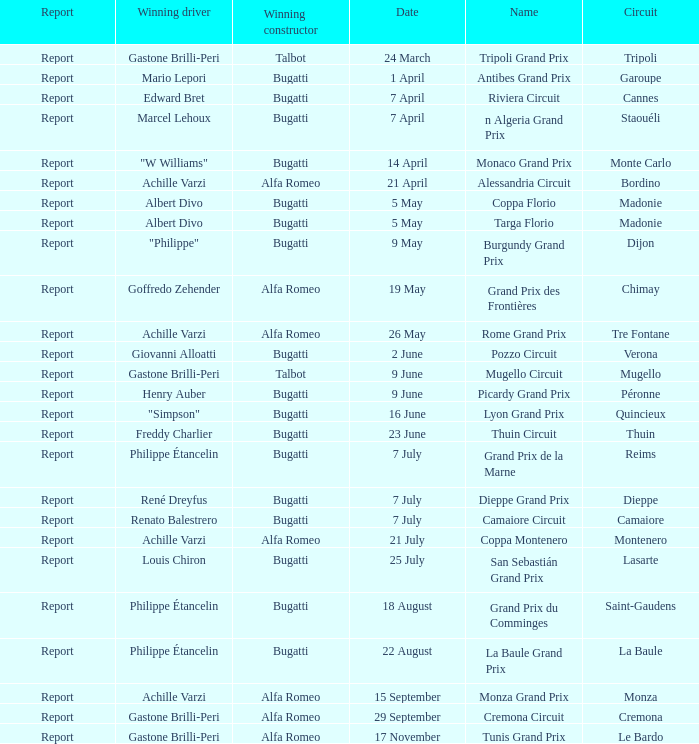What Date has a Name of thuin circuit? 23 June. 